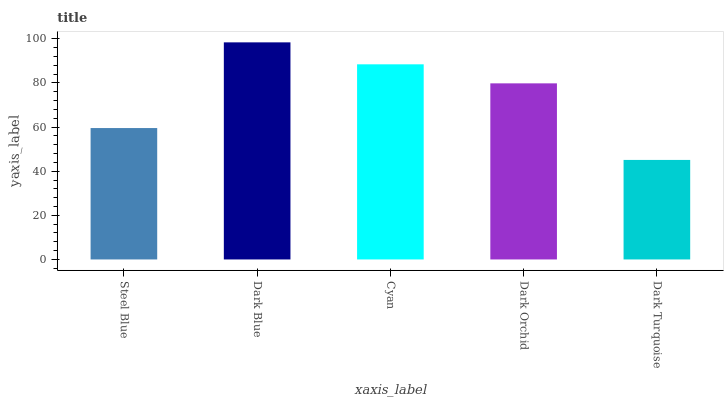Is Dark Turquoise the minimum?
Answer yes or no. Yes. Is Dark Blue the maximum?
Answer yes or no. Yes. Is Cyan the minimum?
Answer yes or no. No. Is Cyan the maximum?
Answer yes or no. No. Is Dark Blue greater than Cyan?
Answer yes or no. Yes. Is Cyan less than Dark Blue?
Answer yes or no. Yes. Is Cyan greater than Dark Blue?
Answer yes or no. No. Is Dark Blue less than Cyan?
Answer yes or no. No. Is Dark Orchid the high median?
Answer yes or no. Yes. Is Dark Orchid the low median?
Answer yes or no. Yes. Is Steel Blue the high median?
Answer yes or no. No. Is Cyan the low median?
Answer yes or no. No. 